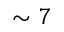Convert formula to latex. <formula><loc_0><loc_0><loc_500><loc_500>\sim 7</formula> 